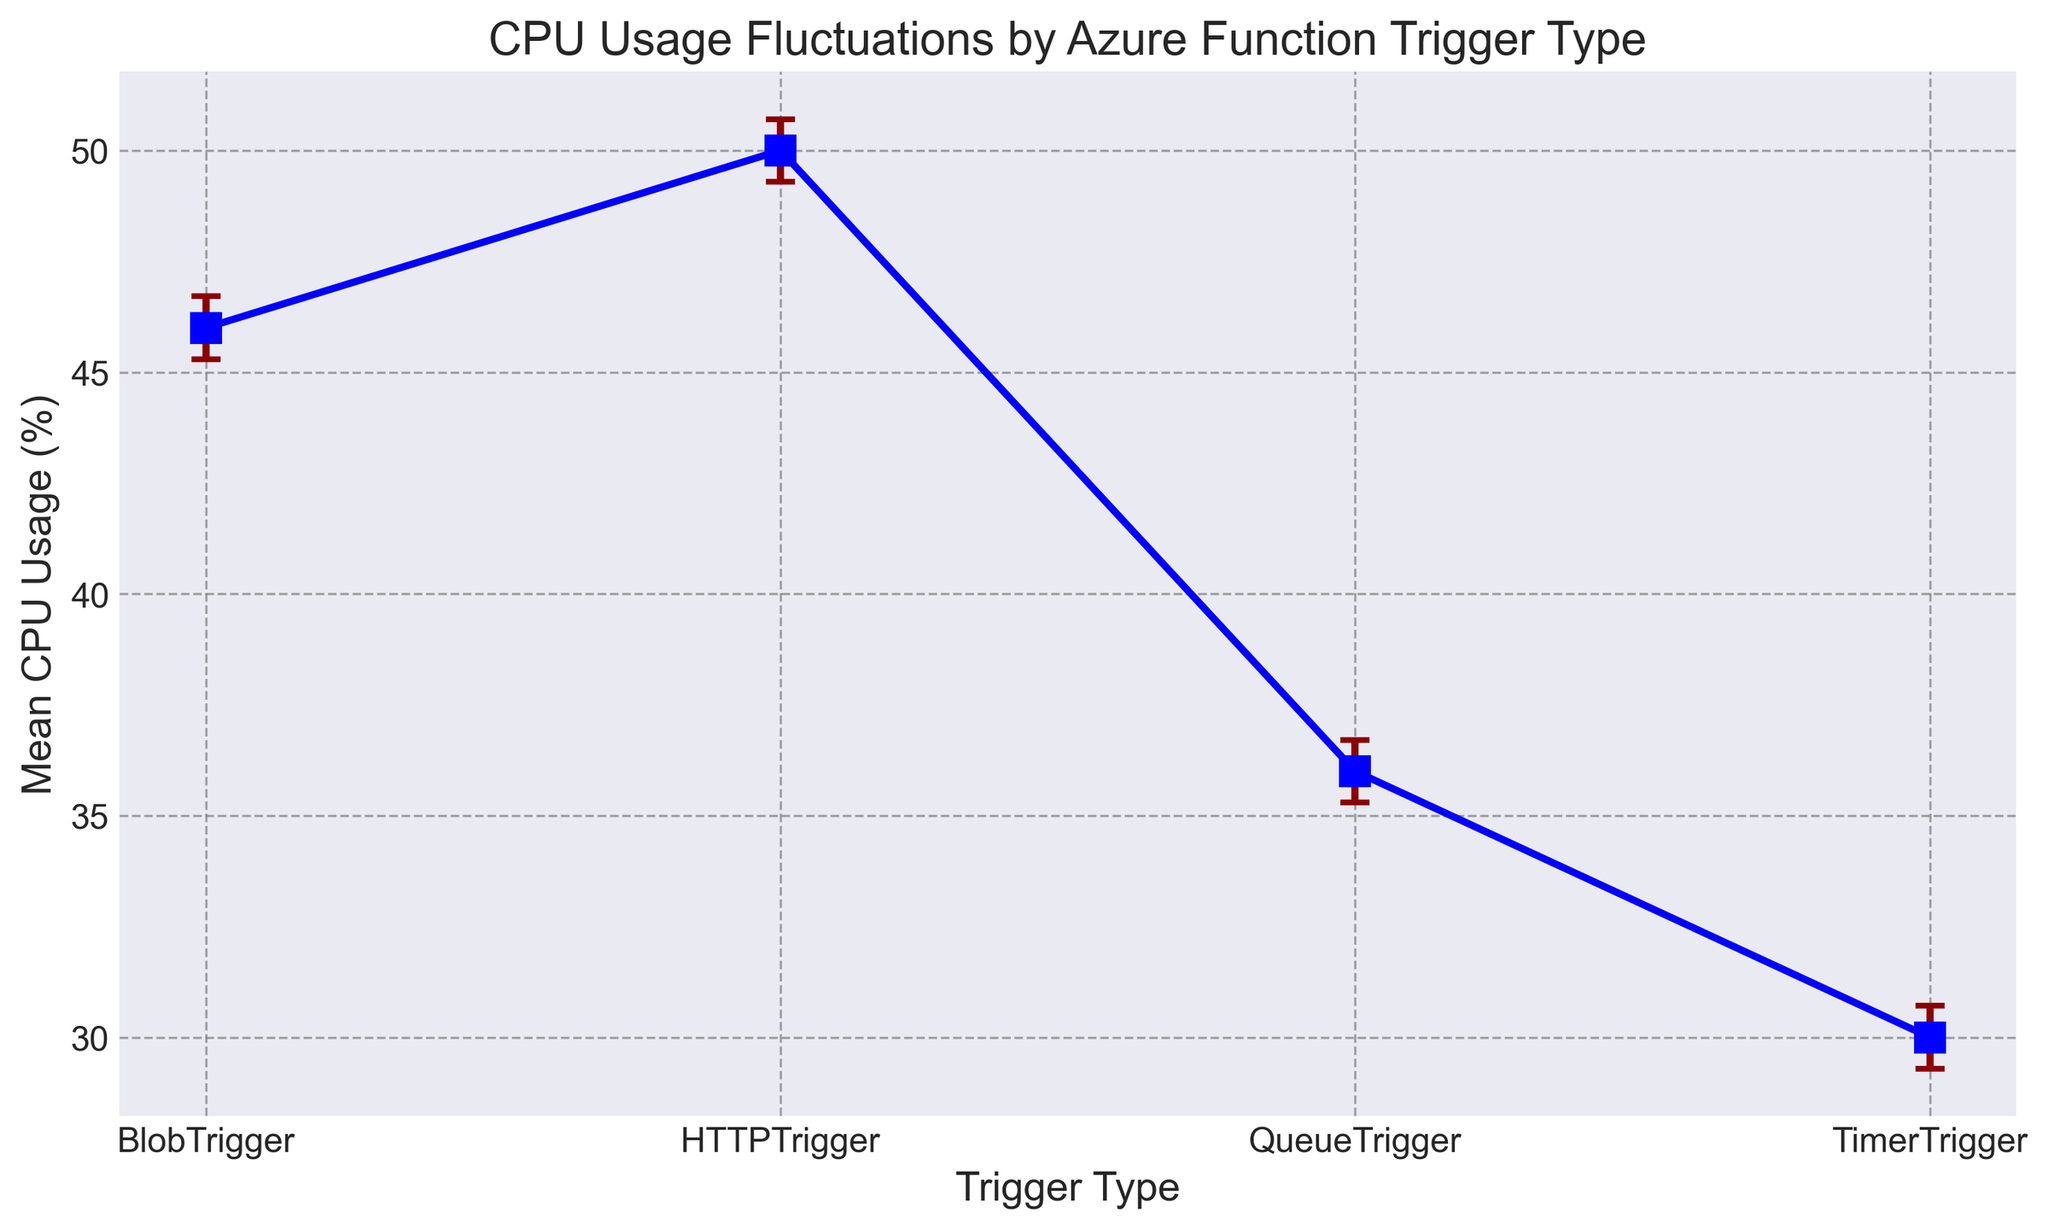Which trigger type shows the highest mean CPU usage? By looking at the height of the markers on the y-axis, we see that the 'HTTPTrigger' has the highest mean CPU usage.
Answer: HTTPTrigger Which trigger type has the largest standard error in mean CPU usage? Largeness of the error bars indicates the standard error; 'BlobTrigger' has the longest error bar.
Answer: BlobTrigger What is the approximate mean CPU usage difference between 'HTTPTrigger' and 'TimerTrigger'? The mean CPU usage for 'HTTPTrigger' is about 50, while for 'TimerTrigger' it is about 30. The difference is 50 - 30 = 20.
Answer: 20 Among all trigger types, which has the smallest mean CPU usage? By looking at the height of the markers on the y-axis, we see that the 'TimerTrigger' has the smallest mean CPU usage.
Answer: TimerTrigger Is there any trigger type with a mean CPU usage close to 45%? Looking at the y-values, 'BlobTrigger' has a mean CPU usage close to 45%.
Answer: BlobTrigger If you average the mean CPU usage of 'QueueTrigger' and 'TimerTrigger', what is the result? The mean CPU usage of 'QueueTrigger' is about 36. The mean CPU usage of 'TimerTrigger' is about 30. The average is (36 + 30) / 2 = 33.
Answer: 33 How does the mean CPU usage of 'QueueTrigger' compare to that of 'HTTPTrigger'? 'QueueTrigger' has a mean CPU usage of about 36%, which is lower than 'HTTPTrigger', which has around 50%.
Answer: Less than Which trigger type has the second-highest mean CPU usage? The second-highest mean CPU usage, by looking at the height of the markers, is 'BlobTrigger'.
Answer: BlobTrigger What is the mean CPU usage for 'BlobTrigger'? By checking the y-axis value for 'BlobTrigger', the mean CPU usage is around 46%.
Answer: 46 